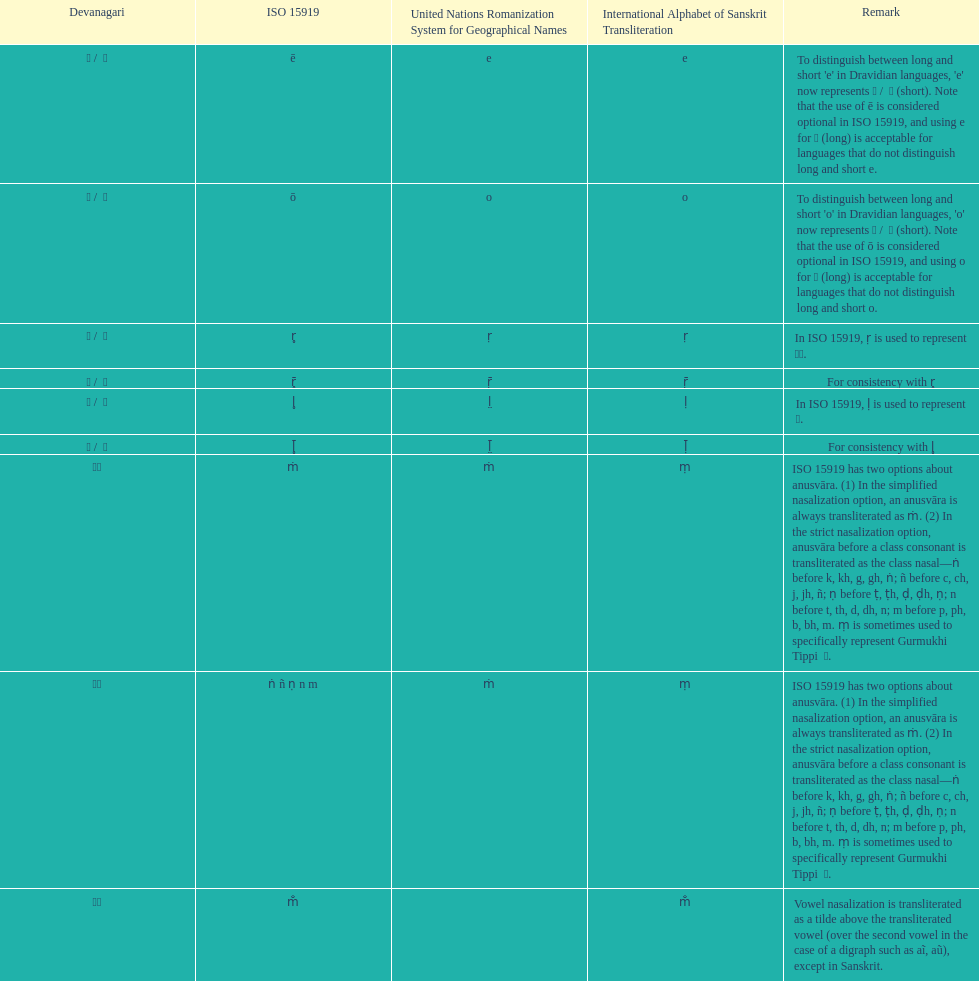This table shows the difference between how many transliterations? 3. 